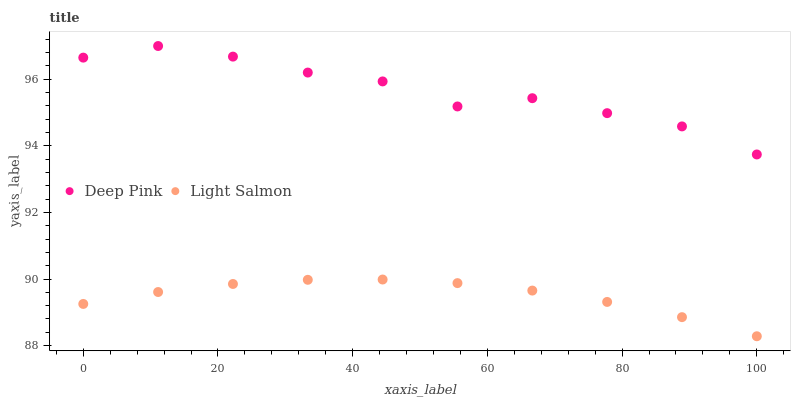Does Light Salmon have the minimum area under the curve?
Answer yes or no. Yes. Does Deep Pink have the maximum area under the curve?
Answer yes or no. Yes. Does Deep Pink have the minimum area under the curve?
Answer yes or no. No. Is Light Salmon the smoothest?
Answer yes or no. Yes. Is Deep Pink the roughest?
Answer yes or no. Yes. Is Deep Pink the smoothest?
Answer yes or no. No. Does Light Salmon have the lowest value?
Answer yes or no. Yes. Does Deep Pink have the lowest value?
Answer yes or no. No. Does Deep Pink have the highest value?
Answer yes or no. Yes. Is Light Salmon less than Deep Pink?
Answer yes or no. Yes. Is Deep Pink greater than Light Salmon?
Answer yes or no. Yes. Does Light Salmon intersect Deep Pink?
Answer yes or no. No. 